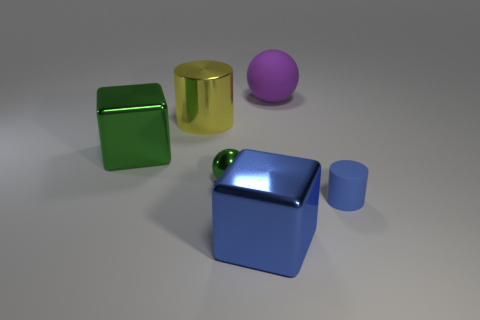How do the objects in the image differ in terms of their surfaces? The objects exhibit a variety of surface finishes. The green square and the golden cylinder have shiny, reflective surfaces indicative of a smooth and possibly metallic finish. In contrast, the purple sphere has a matte finish, diffusing light more evenly, which suggests a non-reflective, perhaps plastic material. The blue cube, while somewhat reflective, has highlights that imply a smoother surface than the purple sphere's but less reflective than the green square or the golden cylinder. 